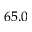<formula> <loc_0><loc_0><loc_500><loc_500>6 5 . 0</formula> 